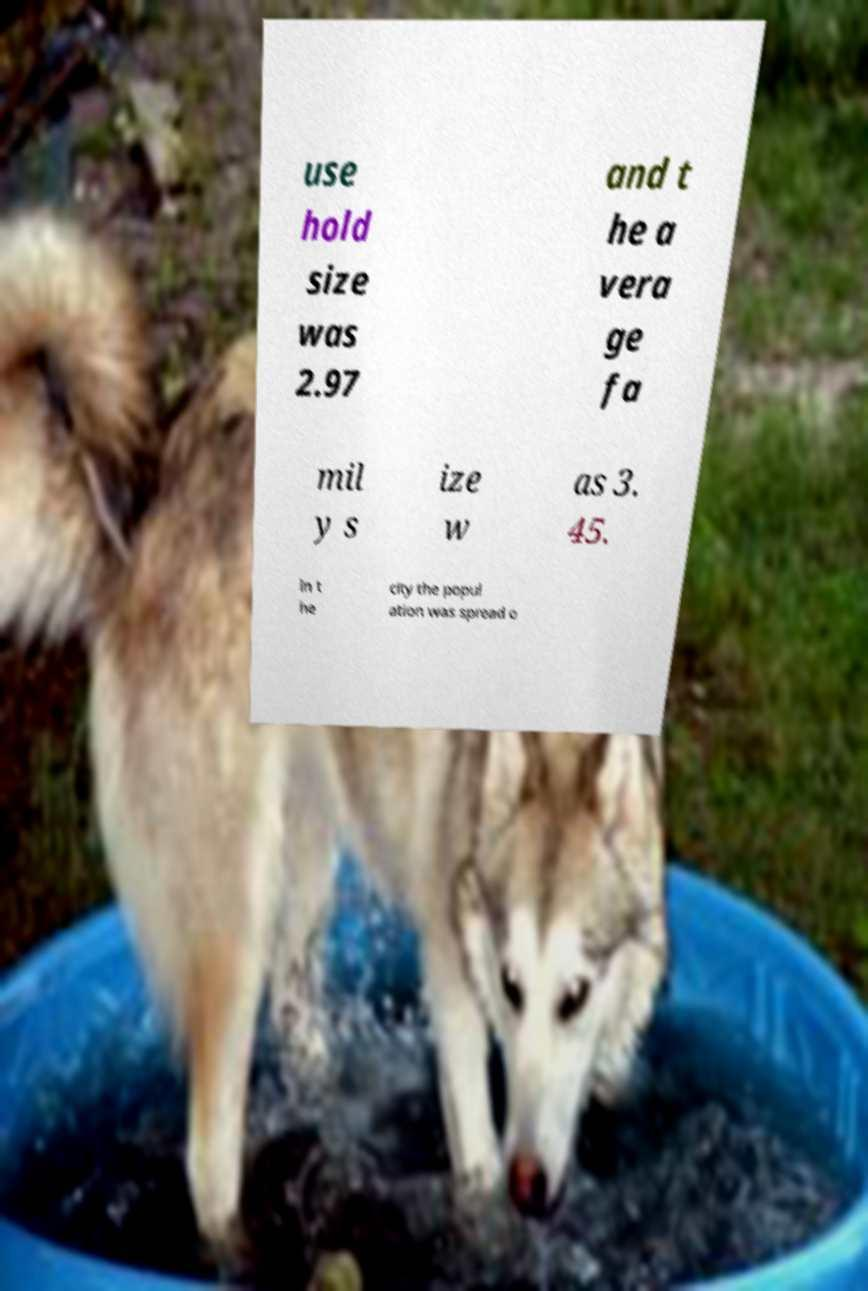There's text embedded in this image that I need extracted. Can you transcribe it verbatim? use hold size was 2.97 and t he a vera ge fa mil y s ize w as 3. 45. In t he city the popul ation was spread o 